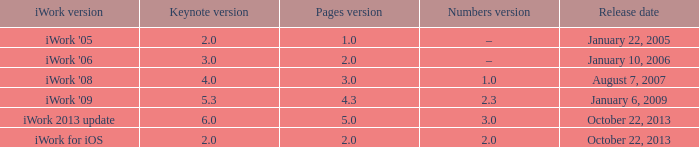What's the latest keynote version of version 2.3 of numbers with pages greater than 4.3? None. 